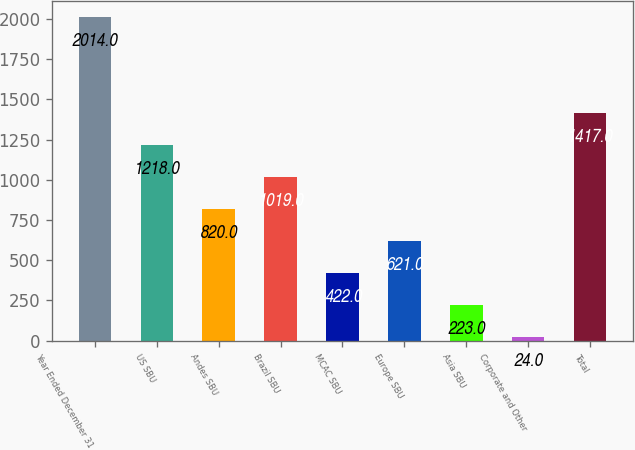<chart> <loc_0><loc_0><loc_500><loc_500><bar_chart><fcel>Year Ended December 31<fcel>US SBU<fcel>Andes SBU<fcel>Brazil SBU<fcel>MCAC SBU<fcel>Europe SBU<fcel>Asia SBU<fcel>Corporate and Other<fcel>Total<nl><fcel>2014<fcel>1218<fcel>820<fcel>1019<fcel>422<fcel>621<fcel>223<fcel>24<fcel>1417<nl></chart> 